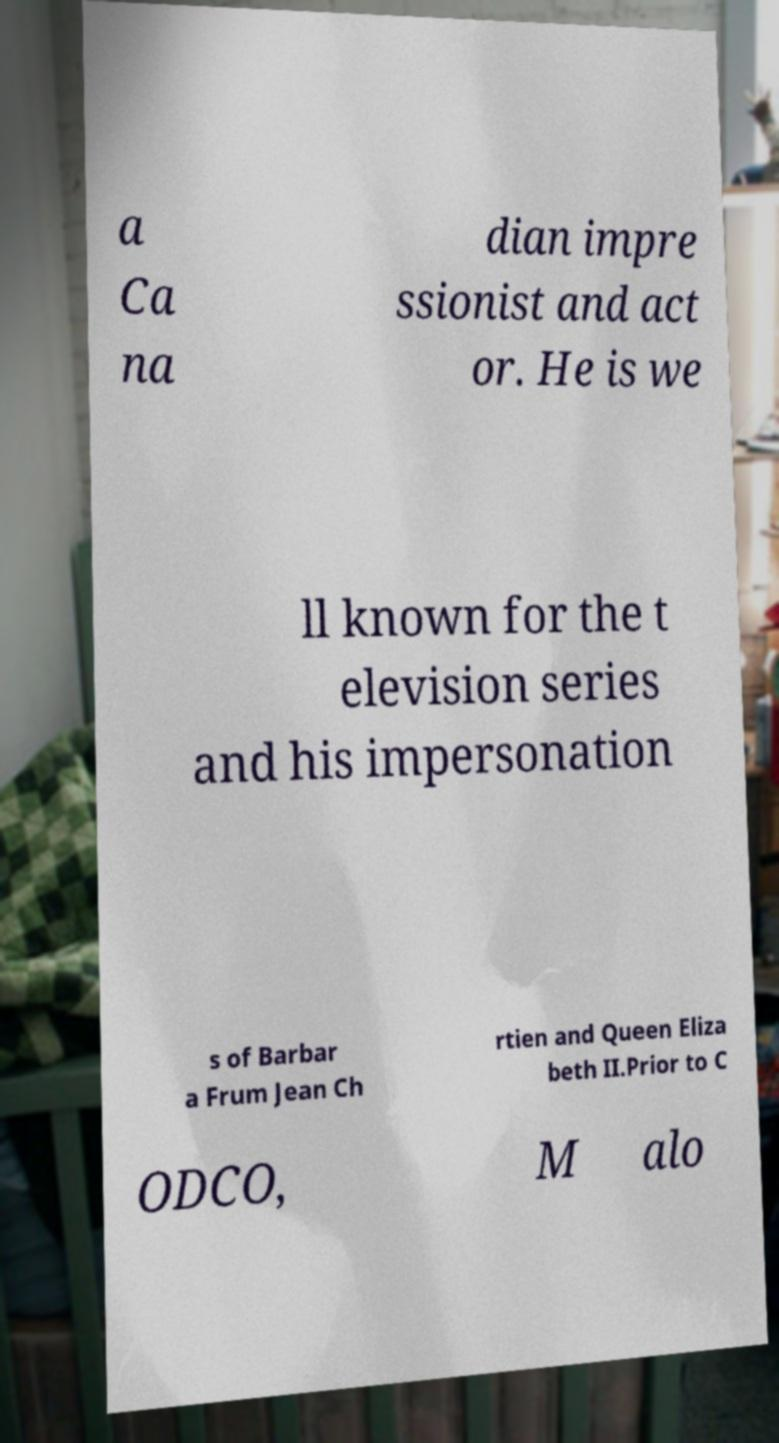Could you assist in decoding the text presented in this image and type it out clearly? a Ca na dian impre ssionist and act or. He is we ll known for the t elevision series and his impersonation s of Barbar a Frum Jean Ch rtien and Queen Eliza beth II.Prior to C ODCO, M alo 